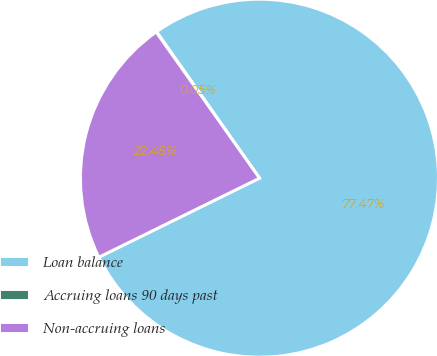<chart> <loc_0><loc_0><loc_500><loc_500><pie_chart><fcel>Loan balance<fcel>Accruing loans 90 days past<fcel>Non-accruing loans<nl><fcel>77.47%<fcel>0.05%<fcel>22.48%<nl></chart> 